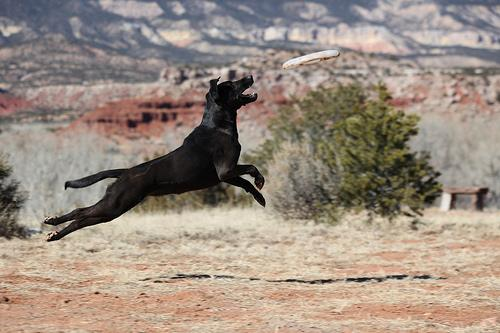Describe the ground in the image. The ground is parched, with dead grass and some patches of green grass, and has a long dark shadow cast on it. Give a concise summary of the entire image. A black dog is jumping to catch a white frisbee in an arid landscape with a gray hillside, red rocks, dead grass, green bushes, a tree, and mountains in the background. What features can you identify about the dog? The dog is black in color, has an open mouth, front legs, tail, paws, and is leaping to catch a frisbee. What is the primary action happening in the image? A black dog is jumping to catch a white frisbee in mid-air. What kind of landscape is depicted in the image? The image depicts an arid landscape with a gray hillside, red rocks, dead grass, and green bushes. Describe the location of the white frisbee relative to the dog. The white frisbee is in the air, slightly above and to the right of the leaping black dog. Can you determine if the dog is successful in catching the frisbee? It is unclear if the dog successfully catches the frisbee, as the image captures the moment when the dog is attempting to catch it in mid-air. What natural element can be found in the background of the image? A large green bush, a tree with leaves and branches, and mountains in the far background can be found. What objects are present in the image's foreground? In the foreground, there is a black dog jumping to catch a white frisbee, red dirt, and a dark shadow cast on the ground. 